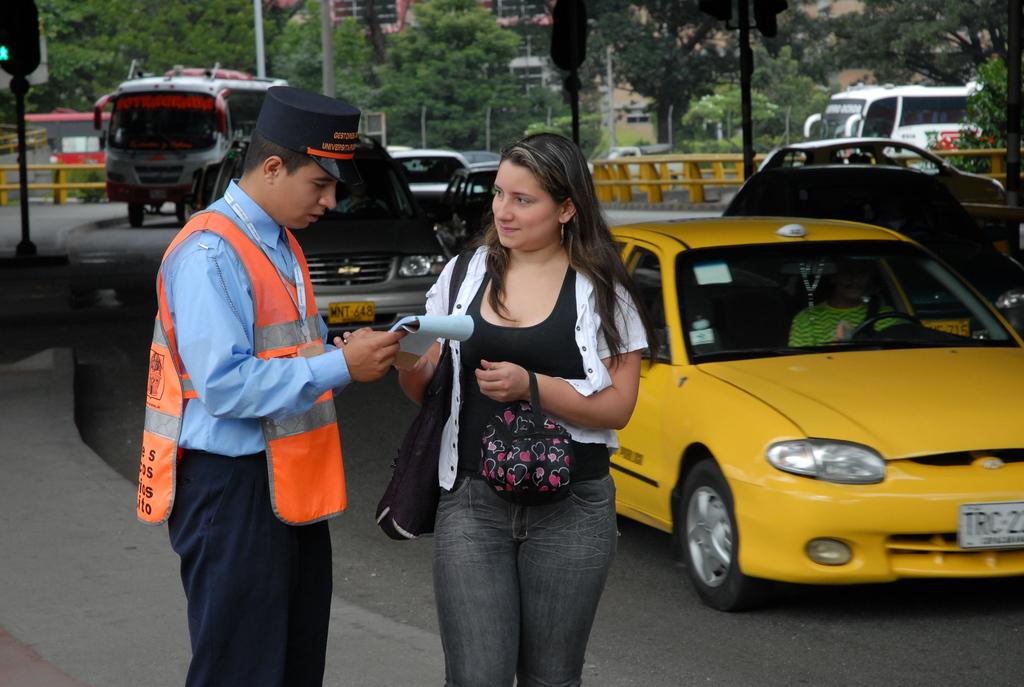What are the first three letters on the taxi's plate?
Your answer should be very brief. Trc. What are the first three letters of the car behind the taxi's license plate?
Keep it short and to the point. Trc. 